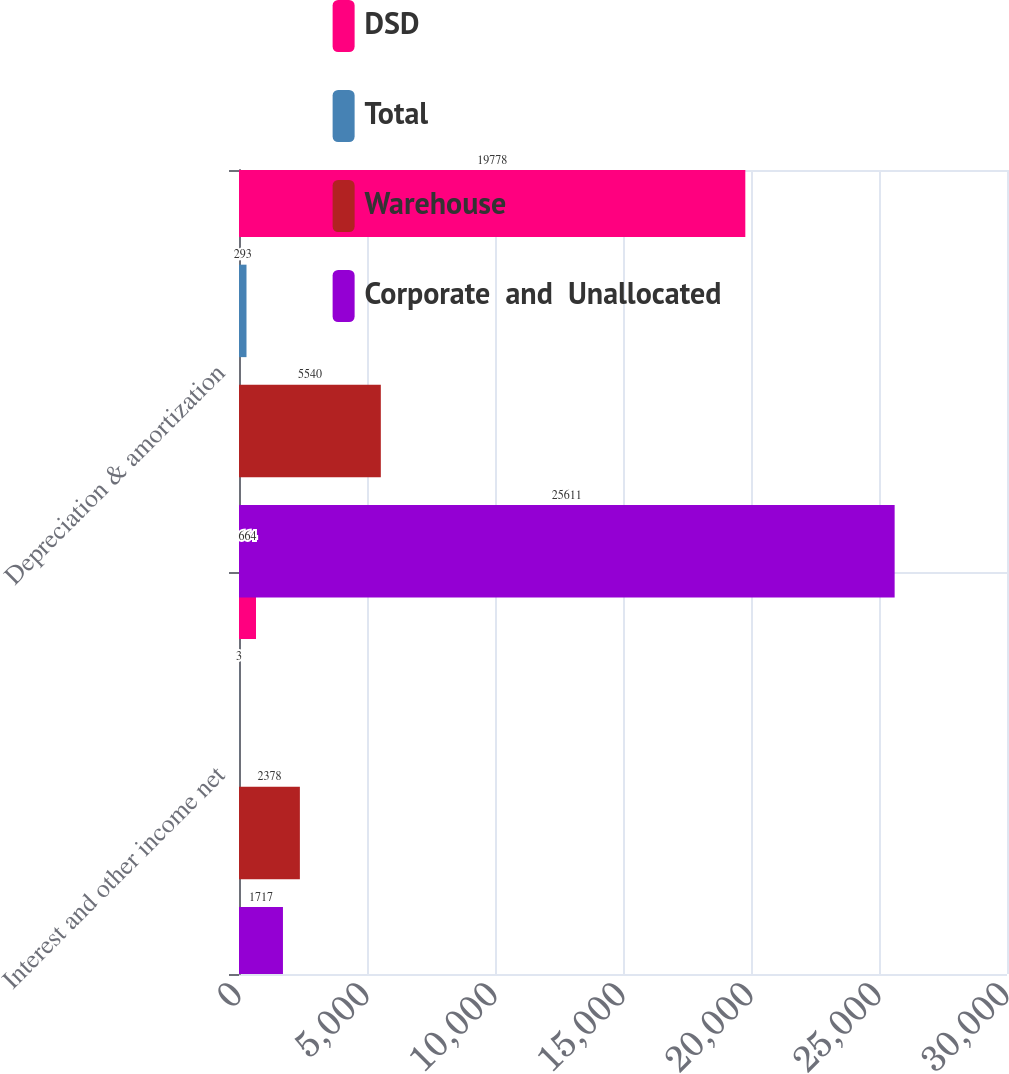Convert chart. <chart><loc_0><loc_0><loc_500><loc_500><stacked_bar_chart><ecel><fcel>Interest and other income net<fcel>Depreciation & amortization<nl><fcel>DSD<fcel>664<fcel>19778<nl><fcel>Total<fcel>3<fcel>293<nl><fcel>Warehouse<fcel>2378<fcel>5540<nl><fcel>Corporate  and  Unallocated<fcel>1717<fcel>25611<nl></chart> 